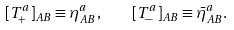<formula> <loc_0><loc_0><loc_500><loc_500>[ T ^ { a } _ { + } ] _ { A B } \equiv \eta ^ { a } _ { A B } , \quad [ T ^ { a } _ { - } ] _ { A B } \equiv \bar { \eta } ^ { a } _ { A B } .</formula> 